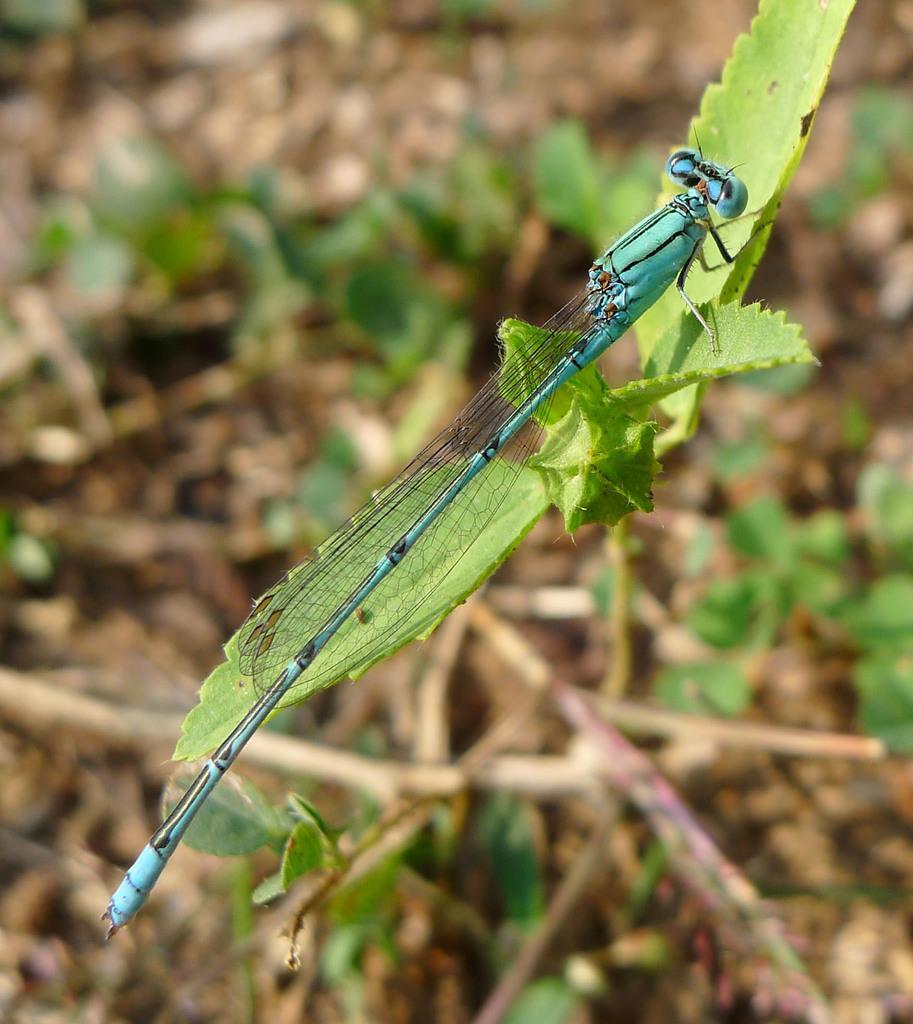In one or two sentences, can you explain what this image depicts? In this picture we can see an insect on leaves and in the background we can see plants and it is blurry. 